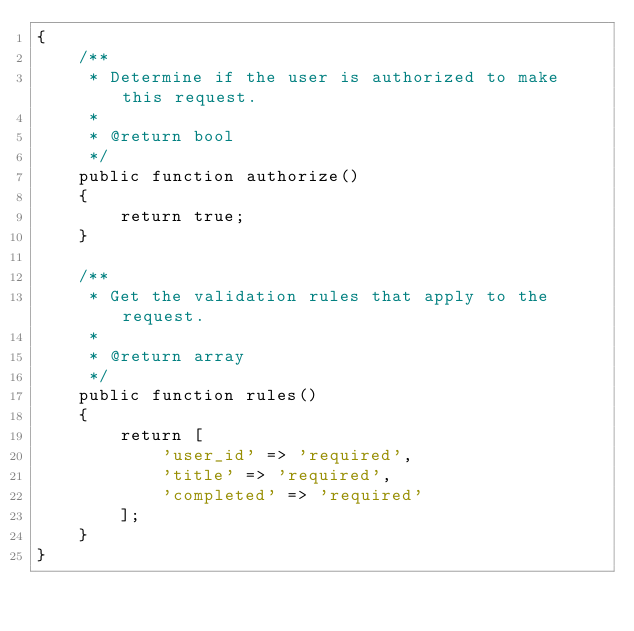Convert code to text. <code><loc_0><loc_0><loc_500><loc_500><_PHP_>{
    /**
     * Determine if the user is authorized to make this request.
     *
     * @return bool
     */
    public function authorize()
    {
        return true;
    }

    /**
     * Get the validation rules that apply to the request.
     *
     * @return array
     */
    public function rules()
    {
        return [
            'user_id' => 'required',
            'title' => 'required',
            'completed' => 'required'
        ];
    }
}
</code> 